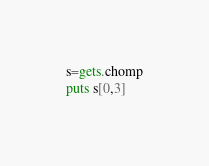<code> <loc_0><loc_0><loc_500><loc_500><_Ruby_>s=gets.chomp
puts s[0,3]</code> 